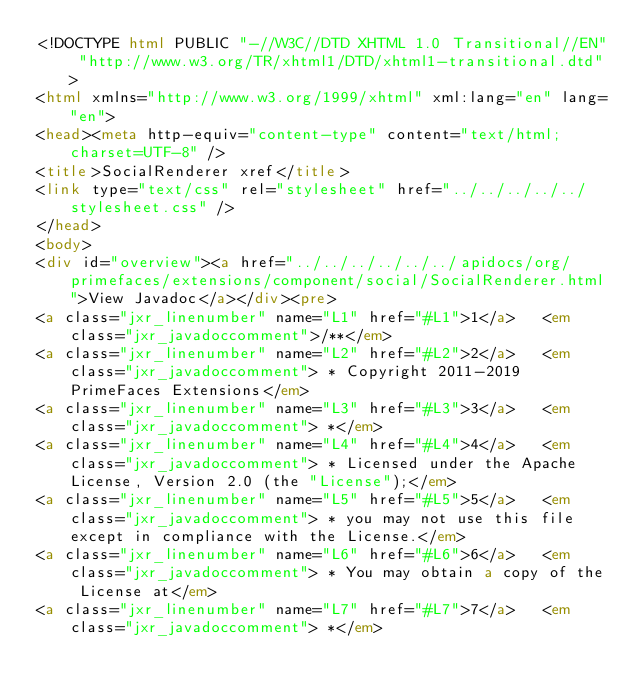<code> <loc_0><loc_0><loc_500><loc_500><_HTML_><!DOCTYPE html PUBLIC "-//W3C//DTD XHTML 1.0 Transitional//EN" "http://www.w3.org/TR/xhtml1/DTD/xhtml1-transitional.dtd">
<html xmlns="http://www.w3.org/1999/xhtml" xml:lang="en" lang="en">
<head><meta http-equiv="content-type" content="text/html; charset=UTF-8" />
<title>SocialRenderer xref</title>
<link type="text/css" rel="stylesheet" href="../../../../../stylesheet.css" />
</head>
<body>
<div id="overview"><a href="../../../../../../apidocs/org/primefaces/extensions/component/social/SocialRenderer.html">View Javadoc</a></div><pre>
<a class="jxr_linenumber" name="L1" href="#L1">1</a>   <em class="jxr_javadoccomment">/**</em>
<a class="jxr_linenumber" name="L2" href="#L2">2</a>   <em class="jxr_javadoccomment"> * Copyright 2011-2019 PrimeFaces Extensions</em>
<a class="jxr_linenumber" name="L3" href="#L3">3</a>   <em class="jxr_javadoccomment"> *</em>
<a class="jxr_linenumber" name="L4" href="#L4">4</a>   <em class="jxr_javadoccomment"> * Licensed under the Apache License, Version 2.0 (the "License");</em>
<a class="jxr_linenumber" name="L5" href="#L5">5</a>   <em class="jxr_javadoccomment"> * you may not use this file except in compliance with the License.</em>
<a class="jxr_linenumber" name="L6" href="#L6">6</a>   <em class="jxr_javadoccomment"> * You may obtain a copy of the License at</em>
<a class="jxr_linenumber" name="L7" href="#L7">7</a>   <em class="jxr_javadoccomment"> *</em></code> 